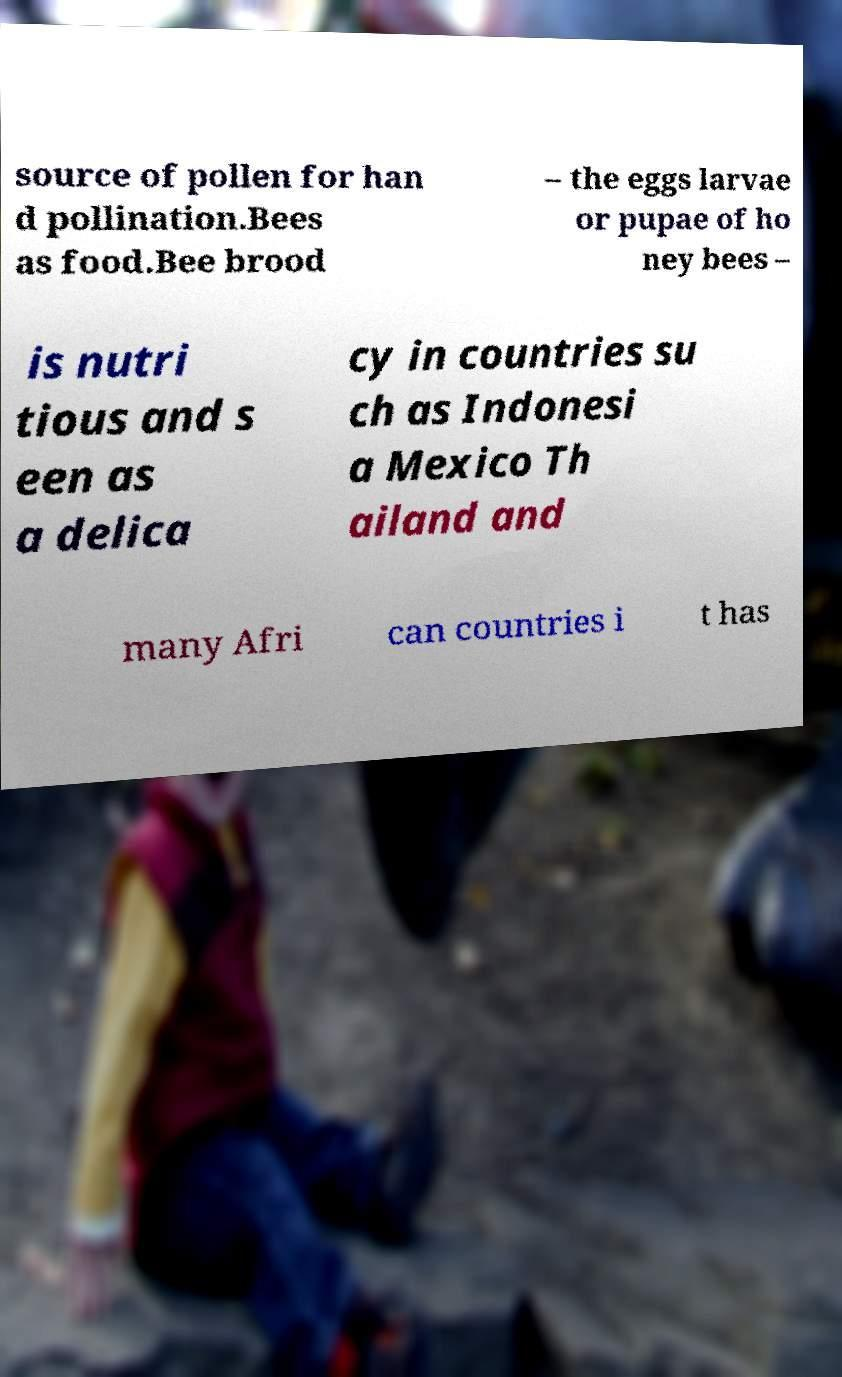Please identify and transcribe the text found in this image. source of pollen for han d pollination.Bees as food.Bee brood – the eggs larvae or pupae of ho ney bees – is nutri tious and s een as a delica cy in countries su ch as Indonesi a Mexico Th ailand and many Afri can countries i t has 